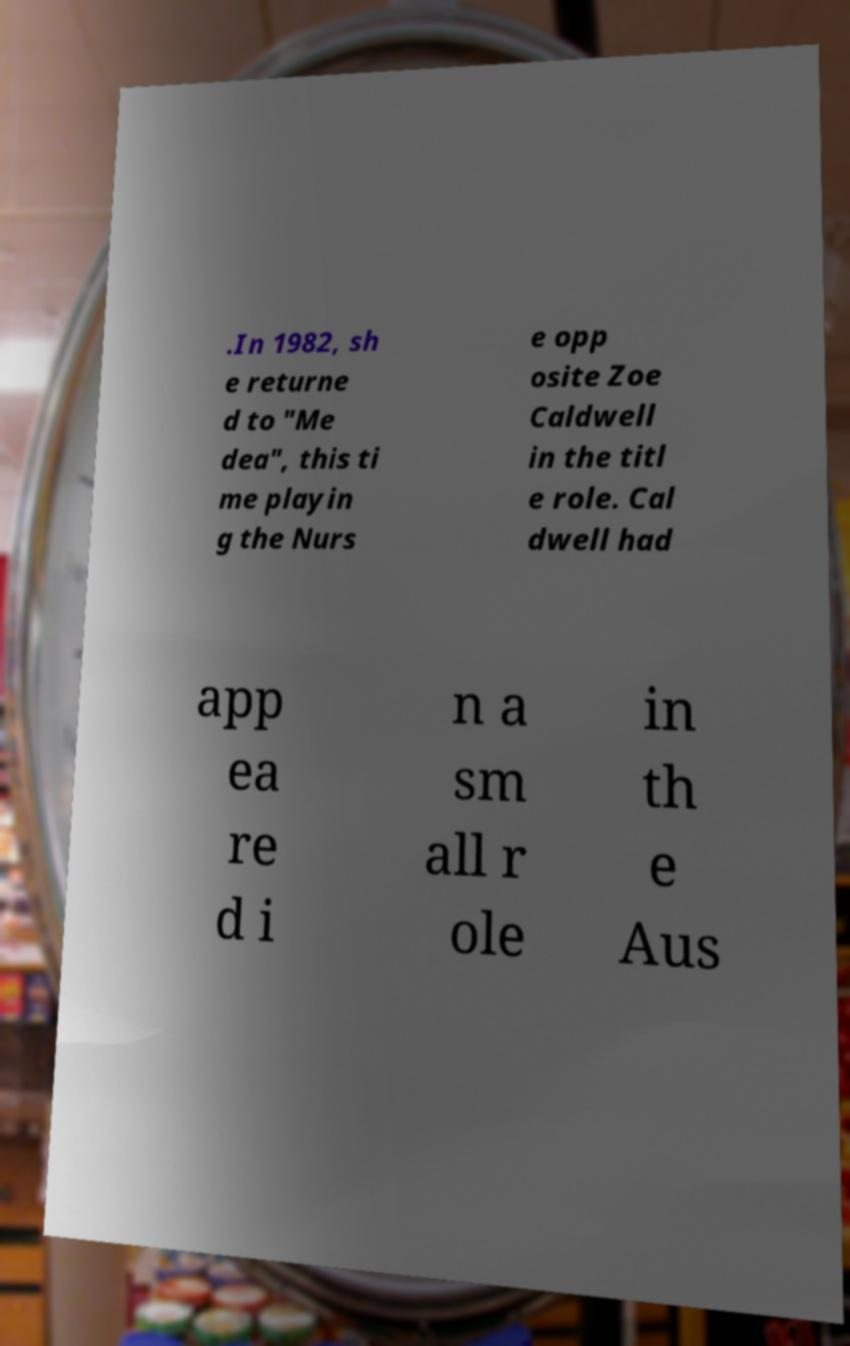I need the written content from this picture converted into text. Can you do that? .In 1982, sh e returne d to "Me dea", this ti me playin g the Nurs e opp osite Zoe Caldwell in the titl e role. Cal dwell had app ea re d i n a sm all r ole in th e Aus 